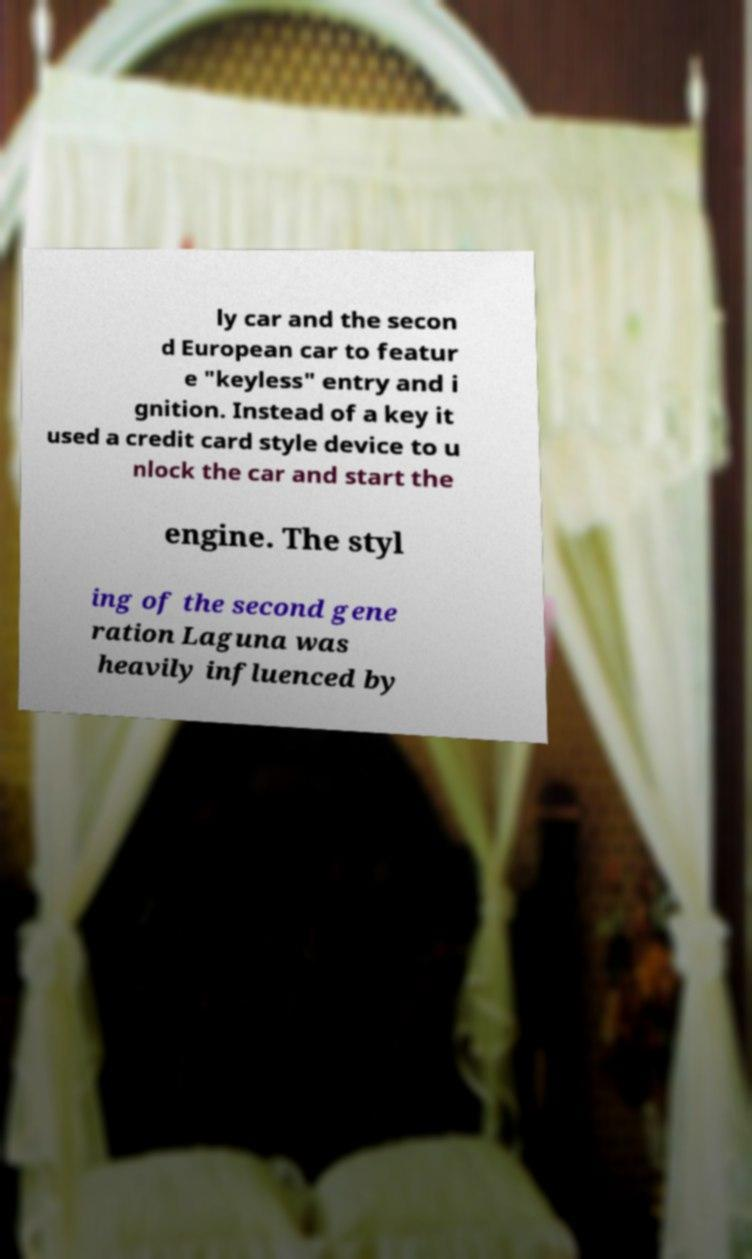There's text embedded in this image that I need extracted. Can you transcribe it verbatim? ly car and the secon d European car to featur e "keyless" entry and i gnition. Instead of a key it used a credit card style device to u nlock the car and start the engine. The styl ing of the second gene ration Laguna was heavily influenced by 